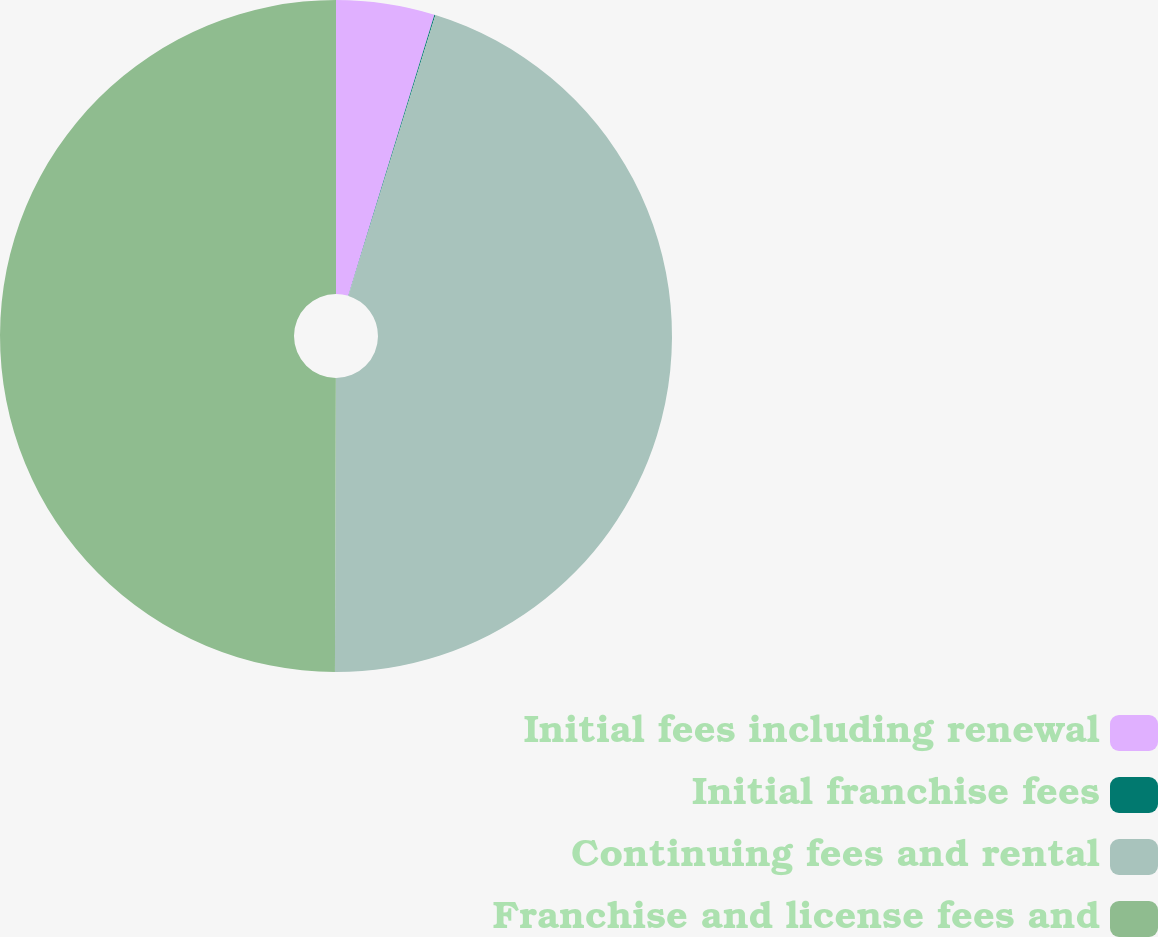Convert chart. <chart><loc_0><loc_0><loc_500><loc_500><pie_chart><fcel>Initial fees including renewal<fcel>Initial franchise fees<fcel>Continuing fees and rental<fcel>Franchise and license fees and<nl><fcel>4.73%<fcel>0.05%<fcel>45.27%<fcel>49.95%<nl></chart> 